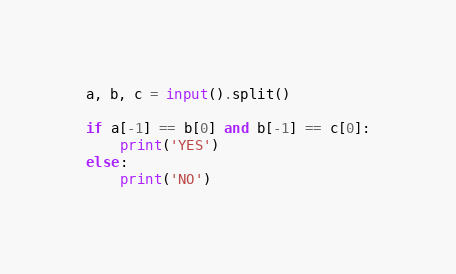<code> <loc_0><loc_0><loc_500><loc_500><_Python_>a, b, c = input().split()

if a[-1] == b[0] and b[-1] == c[0]:
    print('YES')
else:
    print('NO')

</code> 